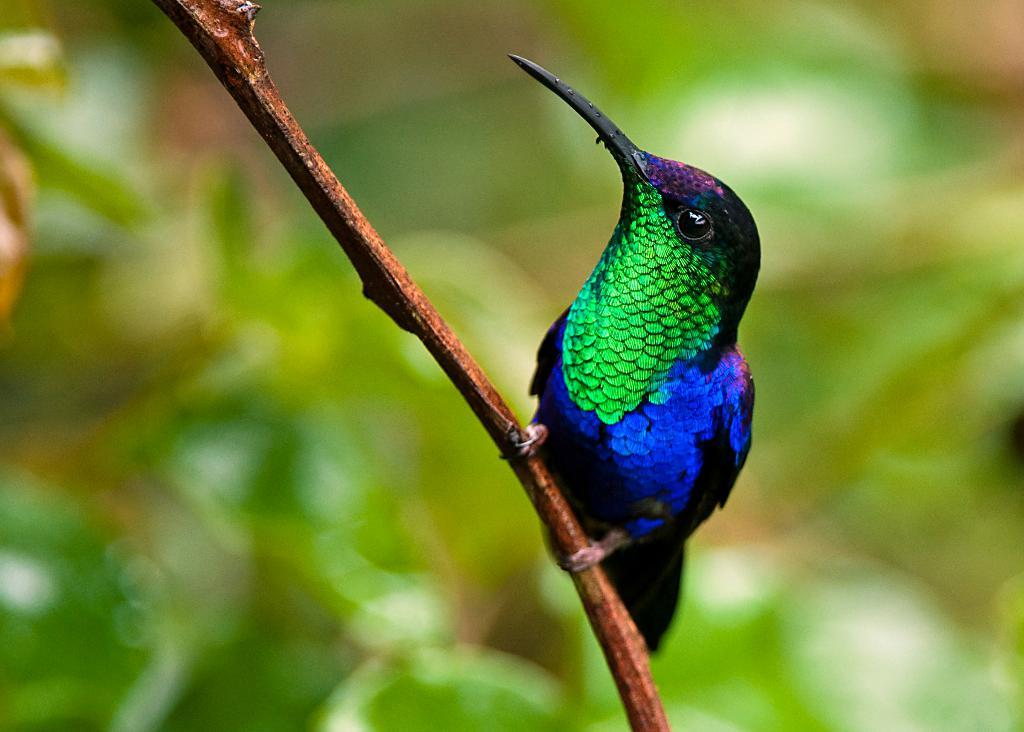What is the main subject of the image? There is a bird in the center of the image. What is the bird standing on? The bird is standing on an object that appears to be a tree branch. Can you describe the background of the image? The background of the image is blurry. What year is depicted in the image? The image does not depict a specific year; it is a photograph of a bird standing on a tree branch. What type of stew is being served in the image? There is no stew present in the image; it features a bird standing on a tree branch. 